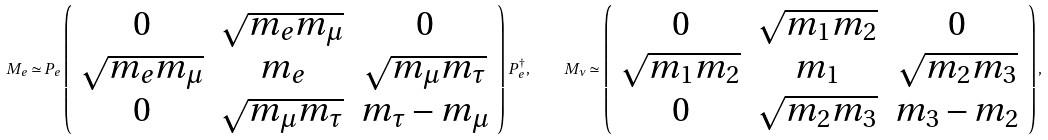Convert formula to latex. <formula><loc_0><loc_0><loc_500><loc_500>M _ { e } \simeq P _ { e } \left ( \begin{array} { c c c } 0 & \sqrt { m _ { e } m _ { \mu } } & 0 \\ \sqrt { m _ { e } m _ { \mu } } & m _ { e } & \sqrt { m _ { \mu } m _ { \tau } } \\ 0 & \sqrt { m _ { \mu } m _ { \tau } } & m _ { \tau } - m _ { \mu } \end{array} \right ) P _ { e } ^ { \dagger } , \quad M _ { \nu } \simeq \left ( \begin{array} { c c c } 0 & \sqrt { m _ { 1 } m _ { 2 } } & 0 \\ \sqrt { m _ { 1 } m _ { 2 } } & m _ { 1 } & \sqrt { m _ { 2 } m _ { 3 } } \\ 0 & \sqrt { m _ { 2 } m _ { 3 } } & m _ { 3 } - m _ { 2 } \end{array} \right ) ,</formula> 